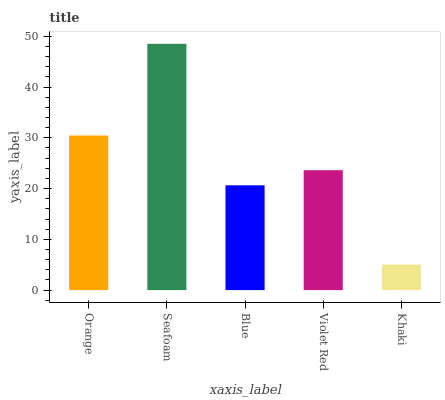Is Blue the minimum?
Answer yes or no. No. Is Blue the maximum?
Answer yes or no. No. Is Seafoam greater than Blue?
Answer yes or no. Yes. Is Blue less than Seafoam?
Answer yes or no. Yes. Is Blue greater than Seafoam?
Answer yes or no. No. Is Seafoam less than Blue?
Answer yes or no. No. Is Violet Red the high median?
Answer yes or no. Yes. Is Violet Red the low median?
Answer yes or no. Yes. Is Blue the high median?
Answer yes or no. No. Is Seafoam the low median?
Answer yes or no. No. 